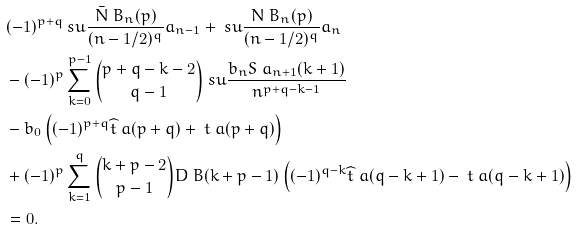Convert formula to latex. <formula><loc_0><loc_0><loc_500><loc_500>& ( - 1 ) ^ { p + q } \ s u \frac { { \bar { N } } \ B _ { n } ( p ) } { ( n - 1 / 2 ) ^ { q } } a _ { n - 1 } + \ s u \frac { N \ B _ { n } ( p ) } { ( n - 1 / 2 ) ^ { q } } a _ { n } \\ & - ( - 1 ) ^ { p } \sum _ { k = 0 } ^ { p - 1 } \binom { p + q - k - 2 } { q - 1 } \ s u \frac { b _ { n } S \ a _ { n + 1 } ( k + 1 ) } { n ^ { p + q - k - 1 } } \\ & - b _ { 0 } \left ( ( - 1 ) ^ { p + q } \widehat { t } \ a ( p + q ) + \ t \ a ( p + q ) \right ) \\ & + ( - 1 ) ^ { p } \sum _ { k = 1 } ^ { q } \binom { k + p - 2 } { p - 1 } D \ B ( k + p - 1 ) \left ( ( - 1 ) ^ { q - k } \widehat { t } \ a ( q - k + 1 ) - \ t \ a ( q - k + 1 ) \right ) \\ & = 0 .</formula> 